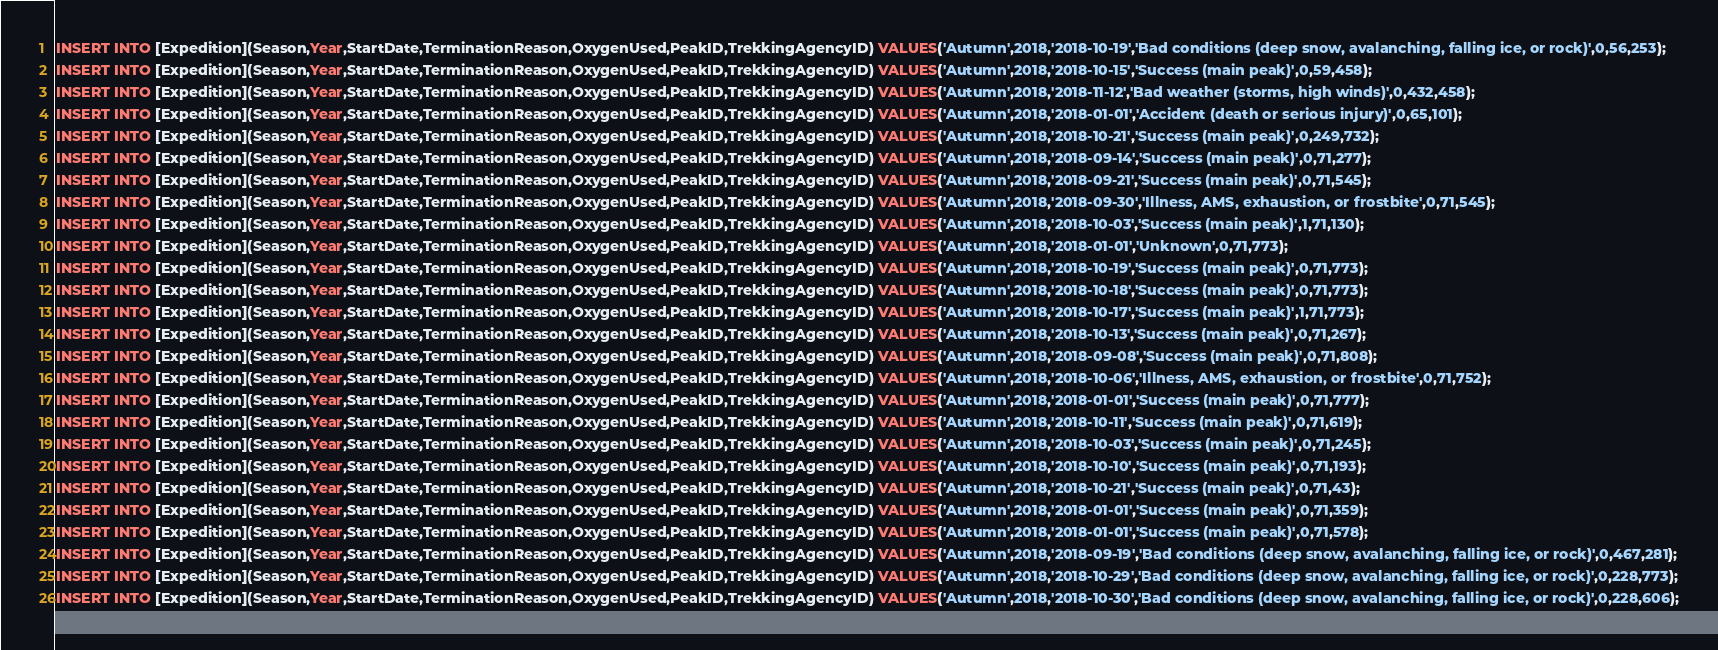<code> <loc_0><loc_0><loc_500><loc_500><_SQL_>INSERT INTO [Expedition](Season,Year,StartDate,TerminationReason,OxygenUsed,PeakID,TrekkingAgencyID) VALUES('Autumn',2018,'2018-10-19','Bad conditions (deep snow, avalanching, falling ice, or rock)',0,56,253);
INSERT INTO [Expedition](Season,Year,StartDate,TerminationReason,OxygenUsed,PeakID,TrekkingAgencyID) VALUES('Autumn',2018,'2018-10-15','Success (main peak)',0,59,458);
INSERT INTO [Expedition](Season,Year,StartDate,TerminationReason,OxygenUsed,PeakID,TrekkingAgencyID) VALUES('Autumn',2018,'2018-11-12','Bad weather (storms, high winds)',0,432,458);
INSERT INTO [Expedition](Season,Year,StartDate,TerminationReason,OxygenUsed,PeakID,TrekkingAgencyID) VALUES('Autumn',2018,'2018-01-01','Accident (death or serious injury)',0,65,101);
INSERT INTO [Expedition](Season,Year,StartDate,TerminationReason,OxygenUsed,PeakID,TrekkingAgencyID) VALUES('Autumn',2018,'2018-10-21','Success (main peak)',0,249,732);
INSERT INTO [Expedition](Season,Year,StartDate,TerminationReason,OxygenUsed,PeakID,TrekkingAgencyID) VALUES('Autumn',2018,'2018-09-14','Success (main peak)',0,71,277);
INSERT INTO [Expedition](Season,Year,StartDate,TerminationReason,OxygenUsed,PeakID,TrekkingAgencyID) VALUES('Autumn',2018,'2018-09-21','Success (main peak)',0,71,545);
INSERT INTO [Expedition](Season,Year,StartDate,TerminationReason,OxygenUsed,PeakID,TrekkingAgencyID) VALUES('Autumn',2018,'2018-09-30','Illness, AMS, exhaustion, or frostbite',0,71,545);
INSERT INTO [Expedition](Season,Year,StartDate,TerminationReason,OxygenUsed,PeakID,TrekkingAgencyID) VALUES('Autumn',2018,'2018-10-03','Success (main peak)',1,71,130);
INSERT INTO [Expedition](Season,Year,StartDate,TerminationReason,OxygenUsed,PeakID,TrekkingAgencyID) VALUES('Autumn',2018,'2018-01-01','Unknown',0,71,773);
INSERT INTO [Expedition](Season,Year,StartDate,TerminationReason,OxygenUsed,PeakID,TrekkingAgencyID) VALUES('Autumn',2018,'2018-10-19','Success (main peak)',0,71,773);
INSERT INTO [Expedition](Season,Year,StartDate,TerminationReason,OxygenUsed,PeakID,TrekkingAgencyID) VALUES('Autumn',2018,'2018-10-18','Success (main peak)',0,71,773);
INSERT INTO [Expedition](Season,Year,StartDate,TerminationReason,OxygenUsed,PeakID,TrekkingAgencyID) VALUES('Autumn',2018,'2018-10-17','Success (main peak)',1,71,773);
INSERT INTO [Expedition](Season,Year,StartDate,TerminationReason,OxygenUsed,PeakID,TrekkingAgencyID) VALUES('Autumn',2018,'2018-10-13','Success (main peak)',0,71,267);
INSERT INTO [Expedition](Season,Year,StartDate,TerminationReason,OxygenUsed,PeakID,TrekkingAgencyID) VALUES('Autumn',2018,'2018-09-08','Success (main peak)',0,71,808);
INSERT INTO [Expedition](Season,Year,StartDate,TerminationReason,OxygenUsed,PeakID,TrekkingAgencyID) VALUES('Autumn',2018,'2018-10-06','Illness, AMS, exhaustion, or frostbite',0,71,752);
INSERT INTO [Expedition](Season,Year,StartDate,TerminationReason,OxygenUsed,PeakID,TrekkingAgencyID) VALUES('Autumn',2018,'2018-01-01','Success (main peak)',0,71,777);
INSERT INTO [Expedition](Season,Year,StartDate,TerminationReason,OxygenUsed,PeakID,TrekkingAgencyID) VALUES('Autumn',2018,'2018-10-11','Success (main peak)',0,71,619);
INSERT INTO [Expedition](Season,Year,StartDate,TerminationReason,OxygenUsed,PeakID,TrekkingAgencyID) VALUES('Autumn',2018,'2018-10-03','Success (main peak)',0,71,245);
INSERT INTO [Expedition](Season,Year,StartDate,TerminationReason,OxygenUsed,PeakID,TrekkingAgencyID) VALUES('Autumn',2018,'2018-10-10','Success (main peak)',0,71,193);
INSERT INTO [Expedition](Season,Year,StartDate,TerminationReason,OxygenUsed,PeakID,TrekkingAgencyID) VALUES('Autumn',2018,'2018-10-21','Success (main peak)',0,71,43);
INSERT INTO [Expedition](Season,Year,StartDate,TerminationReason,OxygenUsed,PeakID,TrekkingAgencyID) VALUES('Autumn',2018,'2018-01-01','Success (main peak)',0,71,359);
INSERT INTO [Expedition](Season,Year,StartDate,TerminationReason,OxygenUsed,PeakID,TrekkingAgencyID) VALUES('Autumn',2018,'2018-01-01','Success (main peak)',0,71,578);
INSERT INTO [Expedition](Season,Year,StartDate,TerminationReason,OxygenUsed,PeakID,TrekkingAgencyID) VALUES('Autumn',2018,'2018-09-19','Bad conditions (deep snow, avalanching, falling ice, or rock)',0,467,281);
INSERT INTO [Expedition](Season,Year,StartDate,TerminationReason,OxygenUsed,PeakID,TrekkingAgencyID) VALUES('Autumn',2018,'2018-10-29','Bad conditions (deep snow, avalanching, falling ice, or rock)',0,228,773);
INSERT INTO [Expedition](Season,Year,StartDate,TerminationReason,OxygenUsed,PeakID,TrekkingAgencyID) VALUES('Autumn',2018,'2018-10-30','Bad conditions (deep snow, avalanching, falling ice, or rock)',0,228,606);</code> 